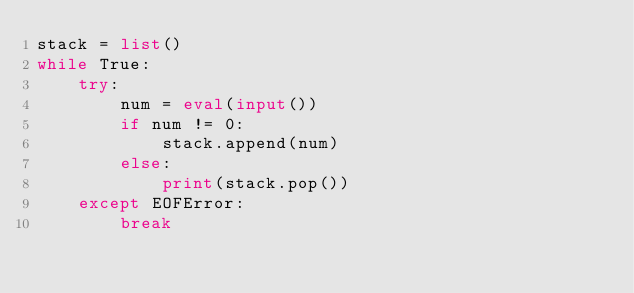Convert code to text. <code><loc_0><loc_0><loc_500><loc_500><_Python_>stack = list()
while True:
	try:
		num = eval(input())
		if num != 0:
			stack.append(num)
		else:
			print(stack.pop())
	except EOFError:
		break</code> 